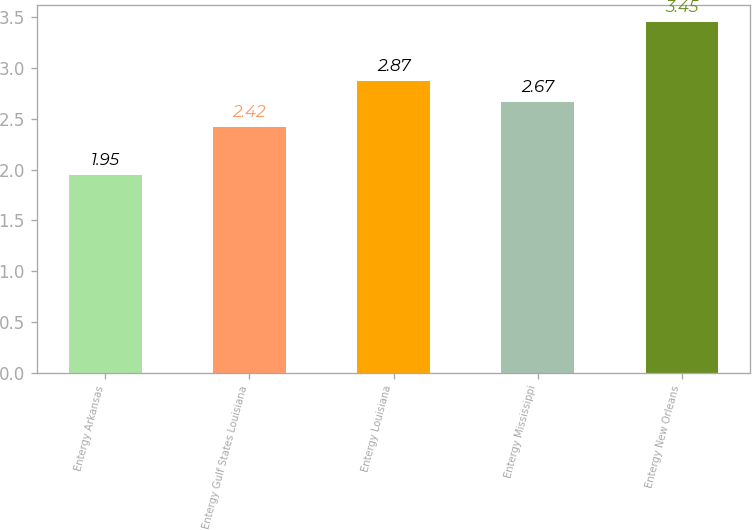<chart> <loc_0><loc_0><loc_500><loc_500><bar_chart><fcel>Entergy Arkansas<fcel>Entergy Gulf States Louisiana<fcel>Entergy Louisiana<fcel>Entergy Mississippi<fcel>Entergy New Orleans<nl><fcel>1.95<fcel>2.42<fcel>2.87<fcel>2.67<fcel>3.45<nl></chart> 